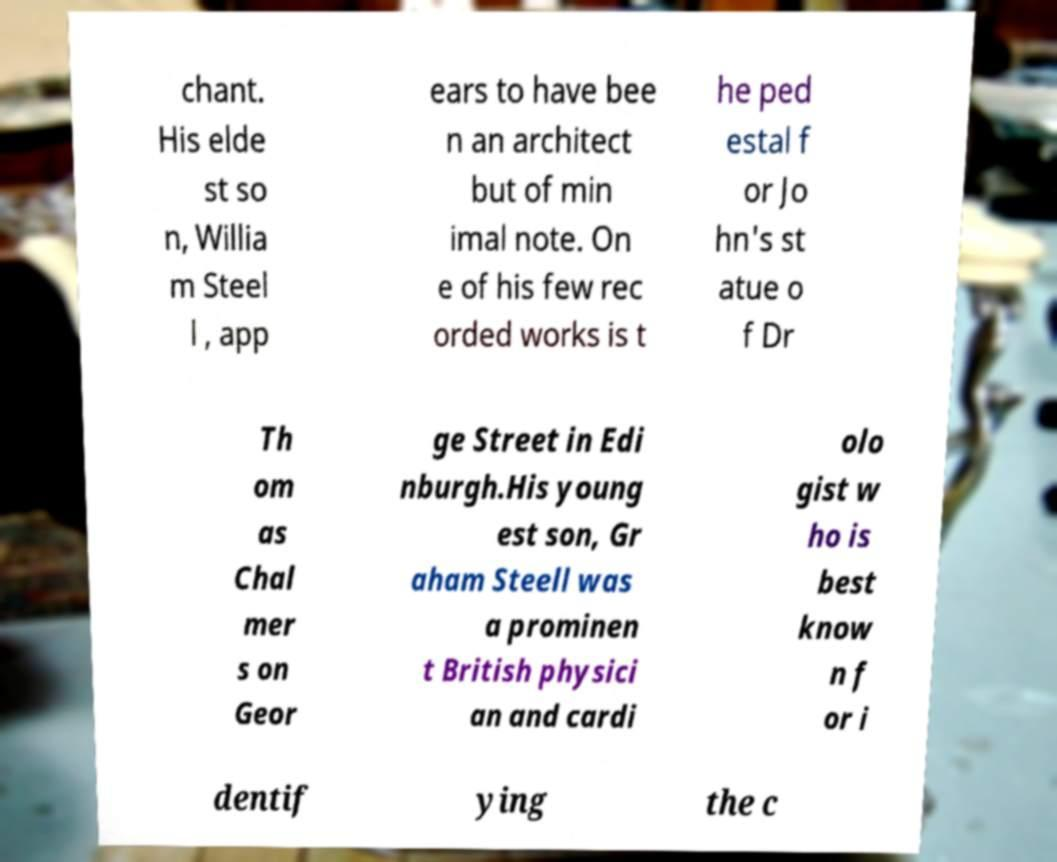Please identify and transcribe the text found in this image. chant. His elde st so n, Willia m Steel l , app ears to have bee n an architect but of min imal note. On e of his few rec orded works is t he ped estal f or Jo hn's st atue o f Dr Th om as Chal mer s on Geor ge Street in Edi nburgh.His young est son, Gr aham Steell was a prominen t British physici an and cardi olo gist w ho is best know n f or i dentif ying the c 